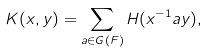<formula> <loc_0><loc_0><loc_500><loc_500>K ( x , y ) = \sum _ { a \in G ( F ) } H ( x ^ { - 1 } a y ) ,</formula> 